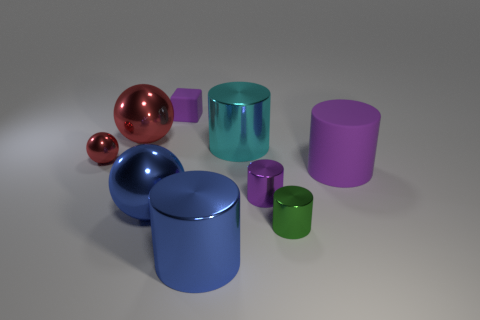What number of things are either big blue metallic balls or small gray metal objects?
Your answer should be very brief. 1. The small ball that is made of the same material as the large red ball is what color?
Give a very brief answer. Red. There is a green metal thing in front of the small purple cylinder; does it have the same shape as the small red metal object?
Make the answer very short. No. What number of things are tiny things in front of the large purple matte thing or blue objects that are behind the tiny green thing?
Keep it short and to the point. 3. The other big rubber object that is the same shape as the large cyan object is what color?
Provide a short and direct response. Purple. Is there any other thing that has the same shape as the tiny purple shiny thing?
Ensure brevity in your answer.  Yes. Does the large cyan object have the same shape as the tiny red thing left of the green cylinder?
Give a very brief answer. No. What is the cyan cylinder made of?
Offer a terse response. Metal. What size is the blue metallic thing that is the same shape as the big red thing?
Offer a very short reply. Large. What number of other things are made of the same material as the large purple cylinder?
Make the answer very short. 1. 